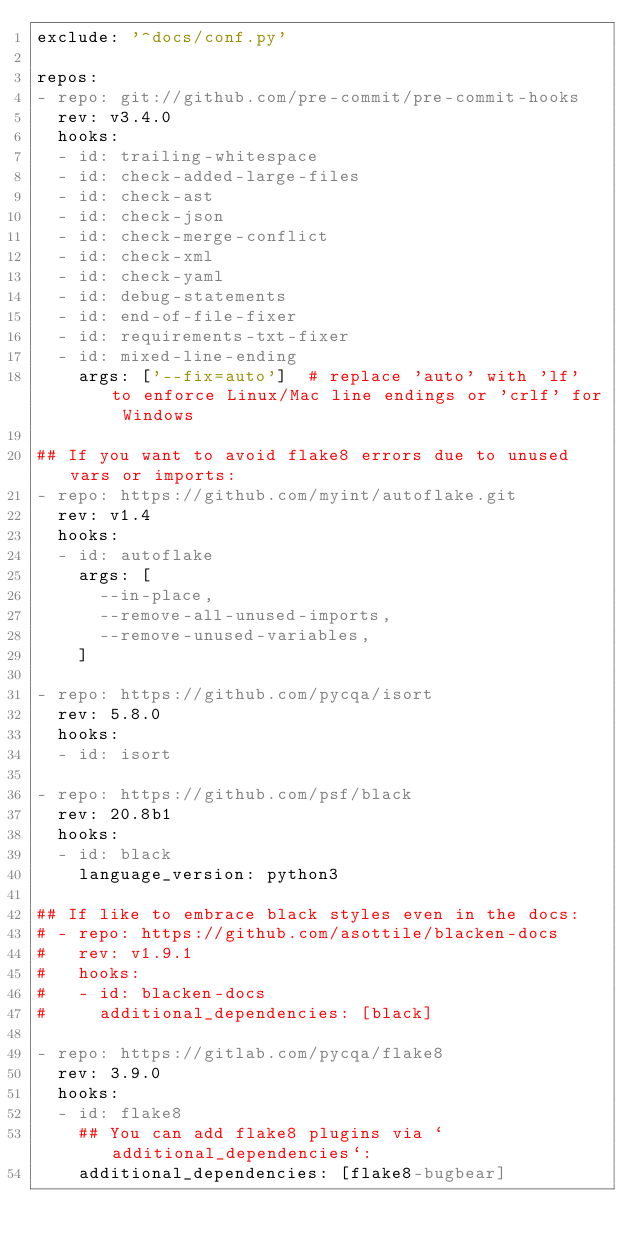<code> <loc_0><loc_0><loc_500><loc_500><_YAML_>exclude: '^docs/conf.py'

repos:
- repo: git://github.com/pre-commit/pre-commit-hooks
  rev: v3.4.0
  hooks:
  - id: trailing-whitespace
  - id: check-added-large-files
  - id: check-ast
  - id: check-json
  - id: check-merge-conflict
  - id: check-xml
  - id: check-yaml
  - id: debug-statements
  - id: end-of-file-fixer
  - id: requirements-txt-fixer
  - id: mixed-line-ending
    args: ['--fix=auto']  # replace 'auto' with 'lf' to enforce Linux/Mac line endings or 'crlf' for Windows

## If you want to avoid flake8 errors due to unused vars or imports:
- repo: https://github.com/myint/autoflake.git
  rev: v1.4
  hooks:
  - id: autoflake
    args: [
      --in-place,
      --remove-all-unused-imports,
      --remove-unused-variables,
    ]

- repo: https://github.com/pycqa/isort
  rev: 5.8.0
  hooks:
  - id: isort

- repo: https://github.com/psf/black
  rev: 20.8b1
  hooks:
  - id: black
    language_version: python3

## If like to embrace black styles even in the docs:
# - repo: https://github.com/asottile/blacken-docs
#   rev: v1.9.1
#   hooks:
#   - id: blacken-docs
#     additional_dependencies: [black]

- repo: https://gitlab.com/pycqa/flake8
  rev: 3.9.0
  hooks:
  - id: flake8
    ## You can add flake8 plugins via `additional_dependencies`:
    additional_dependencies: [flake8-bugbear]
</code> 